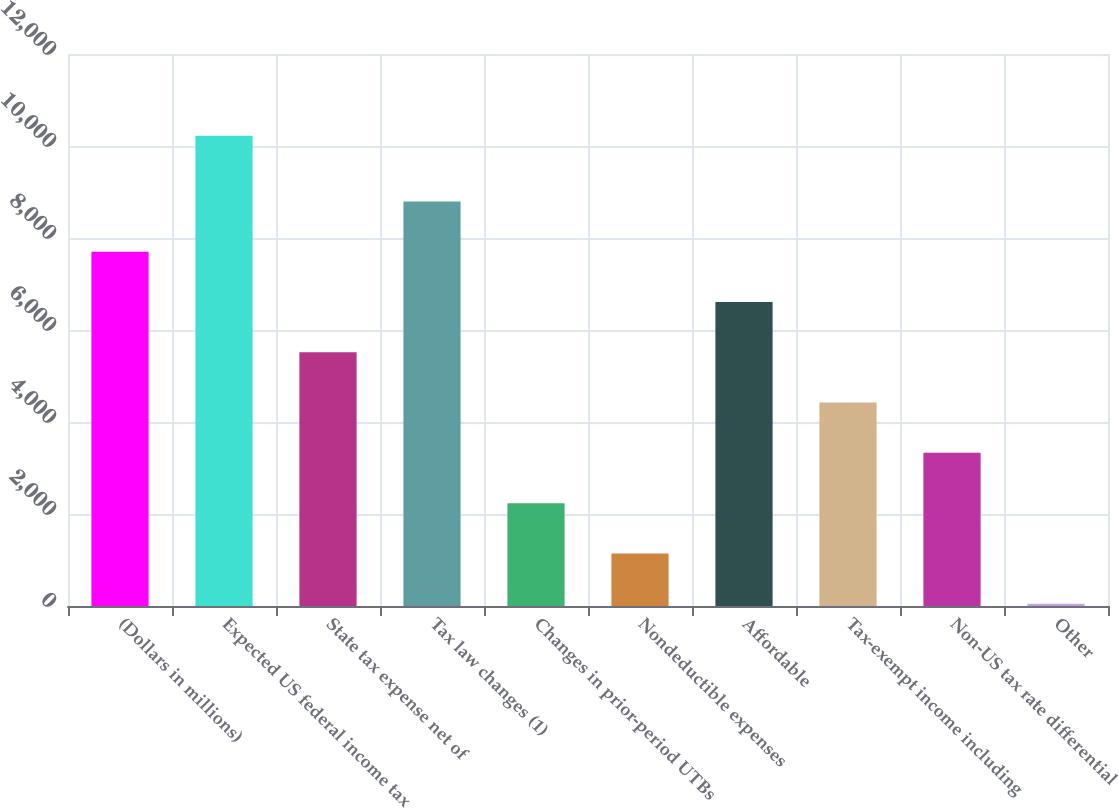<chart> <loc_0><loc_0><loc_500><loc_500><bar_chart><fcel>(Dollars in millions)<fcel>Expected US federal income tax<fcel>State tax expense net of<fcel>Tax law changes (1)<fcel>Changes in prior-period UTBs<fcel>Nondeductible expenses<fcel>Affordable<fcel>Tax-exempt income including<fcel>Non-US tax rate differential<fcel>Other<nl><fcel>7701.7<fcel>10225<fcel>5515.5<fcel>8794.8<fcel>2236.2<fcel>1143.1<fcel>6608.6<fcel>4422.4<fcel>3329.3<fcel>50<nl></chart> 